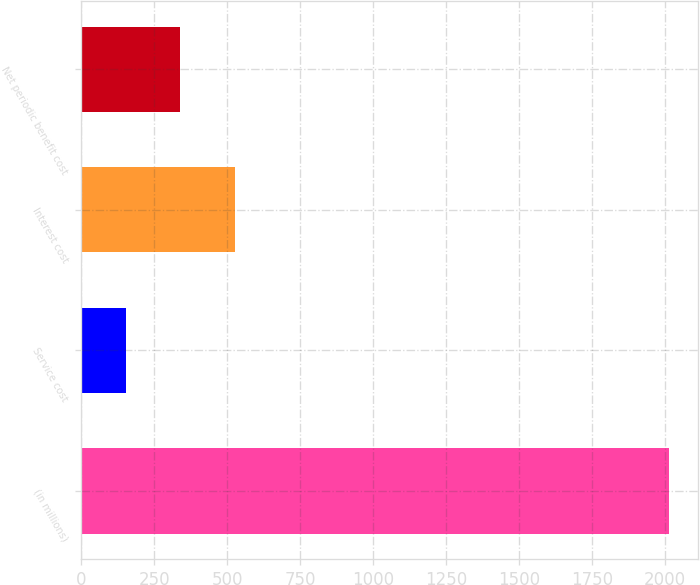<chart> <loc_0><loc_0><loc_500><loc_500><bar_chart><fcel>(in millions)<fcel>Service cost<fcel>Interest cost<fcel>Net periodic benefit cost<nl><fcel>2012<fcel>154<fcel>525.6<fcel>339.8<nl></chart> 